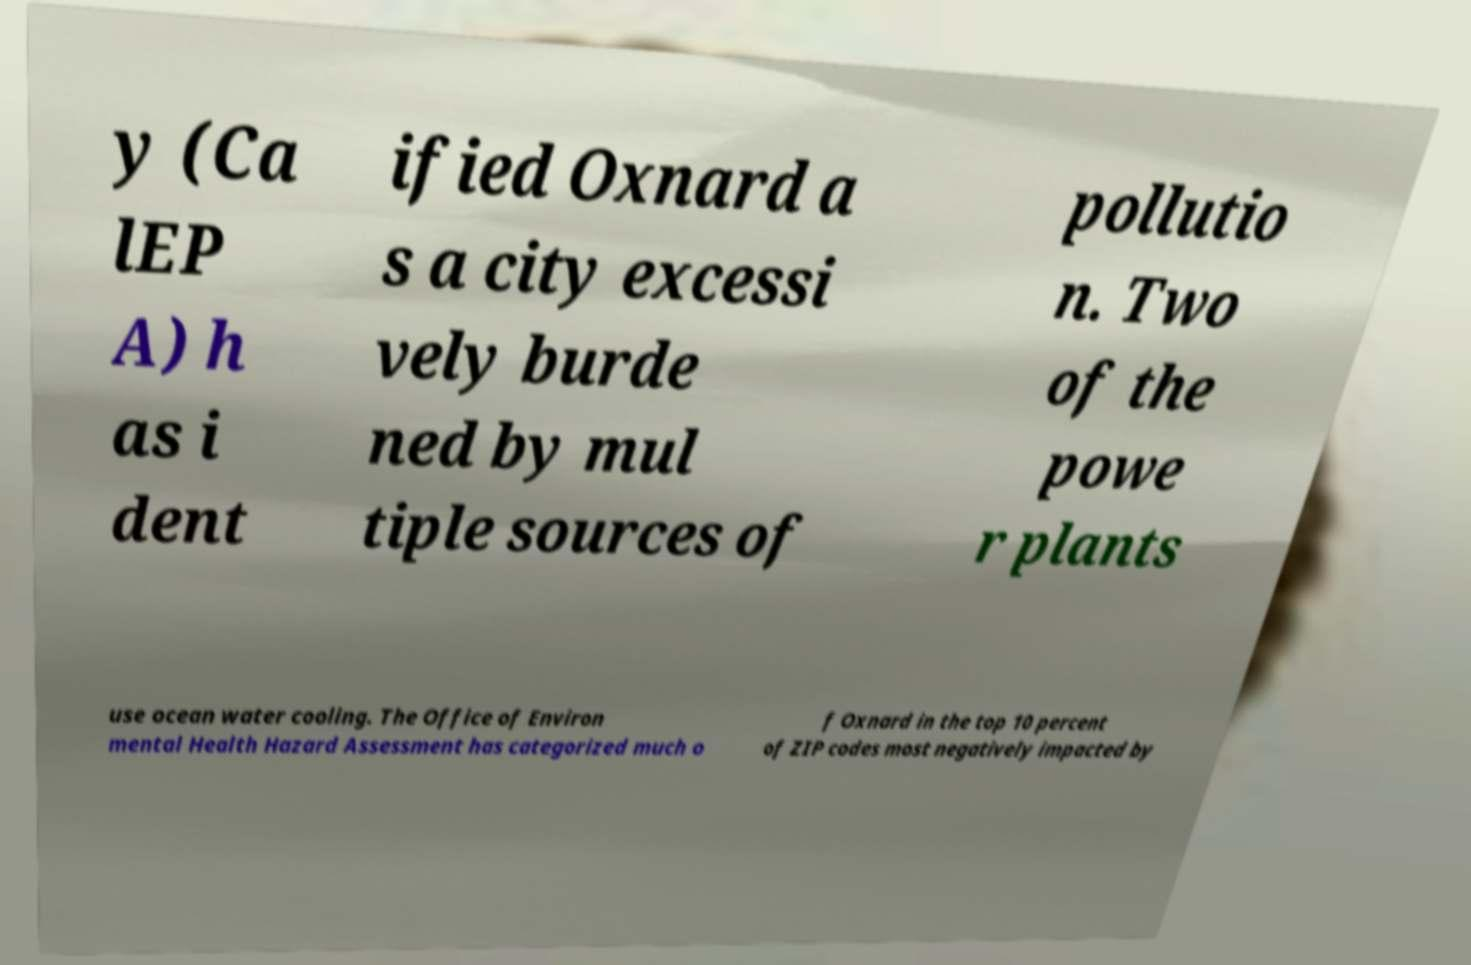Could you assist in decoding the text presented in this image and type it out clearly? y (Ca lEP A) h as i dent ified Oxnard a s a city excessi vely burde ned by mul tiple sources of pollutio n. Two of the powe r plants use ocean water cooling. The Office of Environ mental Health Hazard Assessment has categorized much o f Oxnard in the top 10 percent of ZIP codes most negatively impacted by 